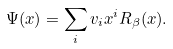Convert formula to latex. <formula><loc_0><loc_0><loc_500><loc_500>\Psi ( x ) = \sum _ { i } v _ { i } x ^ { i } R _ { \beta } ( x ) .</formula> 